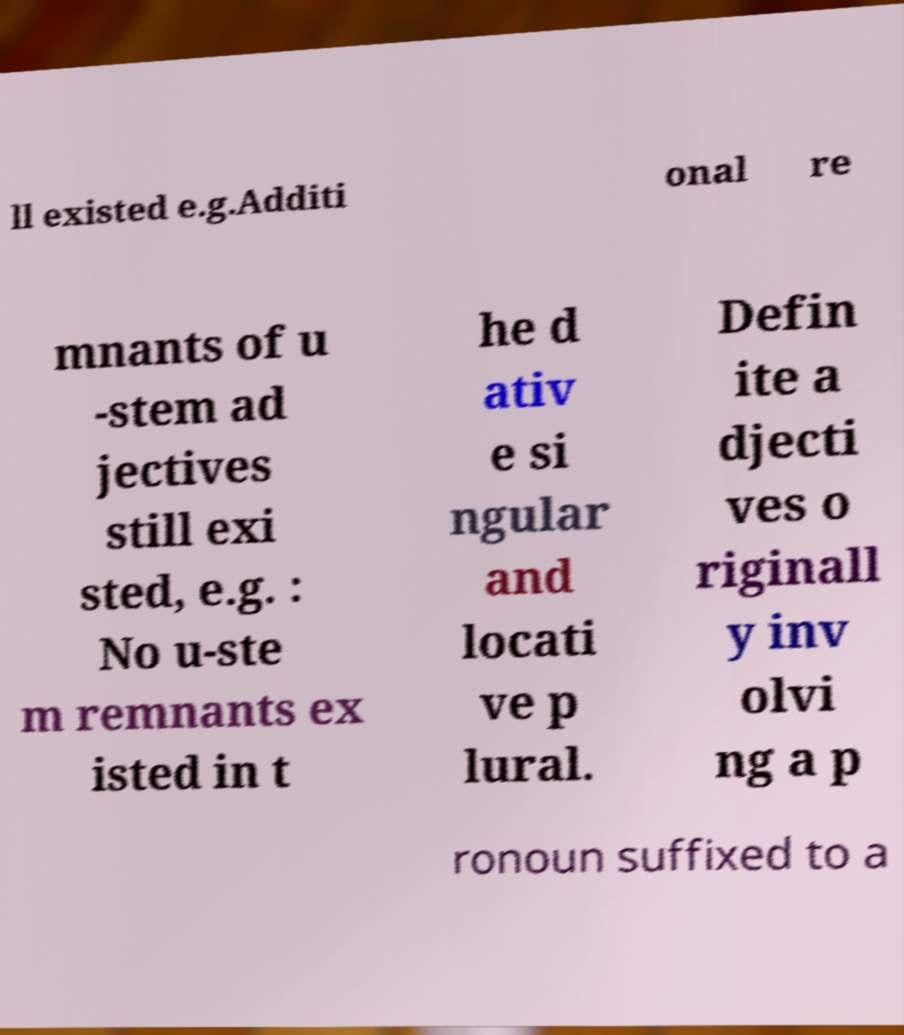Can you accurately transcribe the text from the provided image for me? ll existed e.g.Additi onal re mnants of u -stem ad jectives still exi sted, e.g. : No u-ste m remnants ex isted in t he d ativ e si ngular and locati ve p lural. Defin ite a djecti ves o riginall y inv olvi ng a p ronoun suffixed to a 